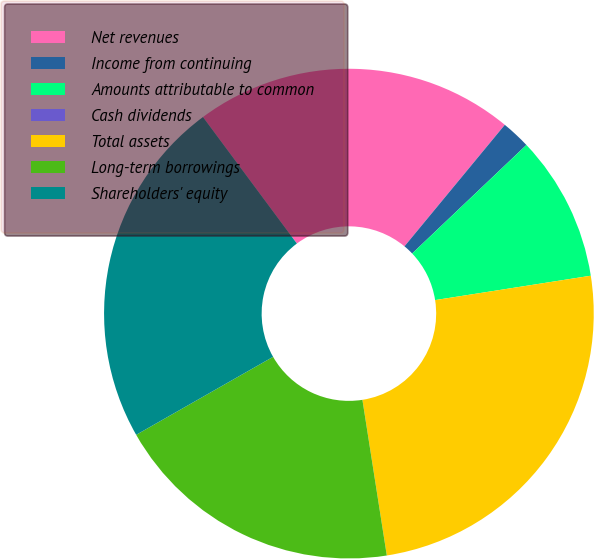<chart> <loc_0><loc_0><loc_500><loc_500><pie_chart><fcel>Net revenues<fcel>Income from continuing<fcel>Amounts attributable to common<fcel>Cash dividends<fcel>Total assets<fcel>Long-term borrowings<fcel>Shareholders' equity<nl><fcel>21.15%<fcel>1.92%<fcel>9.62%<fcel>0.0%<fcel>25.0%<fcel>19.23%<fcel>23.08%<nl></chart> 